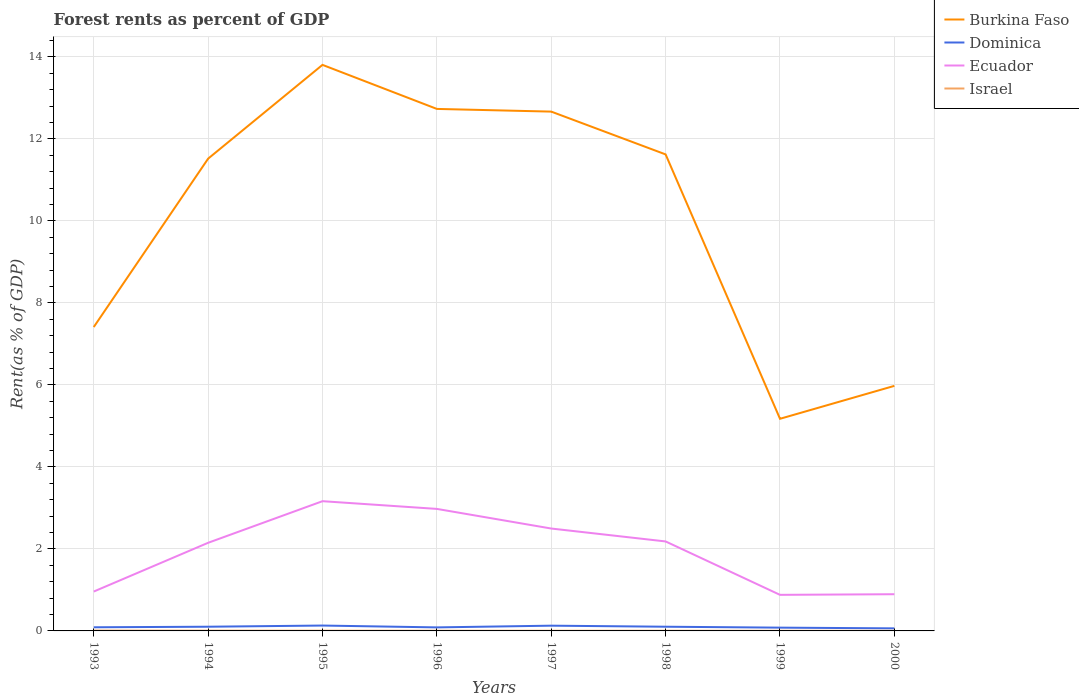How many different coloured lines are there?
Your answer should be compact. 4. Across all years, what is the maximum forest rent in Ecuador?
Offer a terse response. 0.88. What is the total forest rent in Israel in the graph?
Make the answer very short. 0. What is the difference between the highest and the second highest forest rent in Ecuador?
Keep it short and to the point. 2.28. What is the difference between the highest and the lowest forest rent in Dominica?
Your answer should be compact. 4. Is the forest rent in Israel strictly greater than the forest rent in Dominica over the years?
Give a very brief answer. Yes. How many lines are there?
Provide a short and direct response. 4. How many years are there in the graph?
Your response must be concise. 8. What is the difference between two consecutive major ticks on the Y-axis?
Your answer should be very brief. 2. Are the values on the major ticks of Y-axis written in scientific E-notation?
Provide a succinct answer. No. Does the graph contain grids?
Offer a very short reply. Yes. Where does the legend appear in the graph?
Your answer should be very brief. Top right. How are the legend labels stacked?
Provide a short and direct response. Vertical. What is the title of the graph?
Offer a very short reply. Forest rents as percent of GDP. Does "Cyprus" appear as one of the legend labels in the graph?
Offer a very short reply. No. What is the label or title of the X-axis?
Provide a short and direct response. Years. What is the label or title of the Y-axis?
Make the answer very short. Rent(as % of GDP). What is the Rent(as % of GDP) of Burkina Faso in 1993?
Offer a terse response. 7.41. What is the Rent(as % of GDP) in Dominica in 1993?
Your answer should be compact. 0.09. What is the Rent(as % of GDP) in Ecuador in 1993?
Keep it short and to the point. 0.96. What is the Rent(as % of GDP) in Israel in 1993?
Provide a succinct answer. 0.01. What is the Rent(as % of GDP) of Burkina Faso in 1994?
Provide a succinct answer. 11.52. What is the Rent(as % of GDP) in Dominica in 1994?
Provide a succinct answer. 0.1. What is the Rent(as % of GDP) of Ecuador in 1994?
Keep it short and to the point. 2.15. What is the Rent(as % of GDP) in Israel in 1994?
Offer a terse response. 0.01. What is the Rent(as % of GDP) of Burkina Faso in 1995?
Your answer should be compact. 13.81. What is the Rent(as % of GDP) of Dominica in 1995?
Provide a succinct answer. 0.13. What is the Rent(as % of GDP) of Ecuador in 1995?
Provide a short and direct response. 3.16. What is the Rent(as % of GDP) in Israel in 1995?
Give a very brief answer. 0.01. What is the Rent(as % of GDP) in Burkina Faso in 1996?
Provide a succinct answer. 12.73. What is the Rent(as % of GDP) in Dominica in 1996?
Offer a very short reply. 0.09. What is the Rent(as % of GDP) in Ecuador in 1996?
Provide a short and direct response. 2.98. What is the Rent(as % of GDP) in Israel in 1996?
Ensure brevity in your answer.  0. What is the Rent(as % of GDP) in Burkina Faso in 1997?
Provide a succinct answer. 12.67. What is the Rent(as % of GDP) in Dominica in 1997?
Give a very brief answer. 0.13. What is the Rent(as % of GDP) in Ecuador in 1997?
Make the answer very short. 2.5. What is the Rent(as % of GDP) in Israel in 1997?
Keep it short and to the point. 0. What is the Rent(as % of GDP) of Burkina Faso in 1998?
Keep it short and to the point. 11.62. What is the Rent(as % of GDP) of Dominica in 1998?
Offer a terse response. 0.1. What is the Rent(as % of GDP) of Ecuador in 1998?
Your answer should be very brief. 2.18. What is the Rent(as % of GDP) of Israel in 1998?
Provide a succinct answer. 0. What is the Rent(as % of GDP) of Burkina Faso in 1999?
Ensure brevity in your answer.  5.17. What is the Rent(as % of GDP) in Dominica in 1999?
Keep it short and to the point. 0.08. What is the Rent(as % of GDP) of Ecuador in 1999?
Your response must be concise. 0.88. What is the Rent(as % of GDP) of Israel in 1999?
Make the answer very short. 0. What is the Rent(as % of GDP) of Burkina Faso in 2000?
Ensure brevity in your answer.  5.98. What is the Rent(as % of GDP) of Dominica in 2000?
Make the answer very short. 0.06. What is the Rent(as % of GDP) in Ecuador in 2000?
Provide a succinct answer. 0.9. What is the Rent(as % of GDP) of Israel in 2000?
Your answer should be very brief. 0. Across all years, what is the maximum Rent(as % of GDP) in Burkina Faso?
Offer a terse response. 13.81. Across all years, what is the maximum Rent(as % of GDP) in Dominica?
Your answer should be compact. 0.13. Across all years, what is the maximum Rent(as % of GDP) in Ecuador?
Provide a short and direct response. 3.16. Across all years, what is the maximum Rent(as % of GDP) of Israel?
Your answer should be compact. 0.01. Across all years, what is the minimum Rent(as % of GDP) in Burkina Faso?
Make the answer very short. 5.17. Across all years, what is the minimum Rent(as % of GDP) of Dominica?
Offer a very short reply. 0.06. Across all years, what is the minimum Rent(as % of GDP) of Ecuador?
Offer a very short reply. 0.88. Across all years, what is the minimum Rent(as % of GDP) in Israel?
Offer a very short reply. 0. What is the total Rent(as % of GDP) in Burkina Faso in the graph?
Ensure brevity in your answer.  80.91. What is the total Rent(as % of GDP) of Dominica in the graph?
Ensure brevity in your answer.  0.78. What is the total Rent(as % of GDP) of Ecuador in the graph?
Provide a succinct answer. 15.71. What is the total Rent(as % of GDP) in Israel in the graph?
Ensure brevity in your answer.  0.04. What is the difference between the Rent(as % of GDP) in Burkina Faso in 1993 and that in 1994?
Provide a succinct answer. -4.11. What is the difference between the Rent(as % of GDP) in Dominica in 1993 and that in 1994?
Offer a terse response. -0.01. What is the difference between the Rent(as % of GDP) in Ecuador in 1993 and that in 1994?
Provide a succinct answer. -1.19. What is the difference between the Rent(as % of GDP) in Israel in 1993 and that in 1994?
Your answer should be very brief. 0. What is the difference between the Rent(as % of GDP) of Burkina Faso in 1993 and that in 1995?
Provide a succinct answer. -6.39. What is the difference between the Rent(as % of GDP) in Dominica in 1993 and that in 1995?
Make the answer very short. -0.04. What is the difference between the Rent(as % of GDP) in Ecuador in 1993 and that in 1995?
Your answer should be compact. -2.2. What is the difference between the Rent(as % of GDP) of Israel in 1993 and that in 1995?
Your response must be concise. 0. What is the difference between the Rent(as % of GDP) in Burkina Faso in 1993 and that in 1996?
Offer a very short reply. -5.32. What is the difference between the Rent(as % of GDP) in Dominica in 1993 and that in 1996?
Offer a terse response. 0. What is the difference between the Rent(as % of GDP) of Ecuador in 1993 and that in 1996?
Ensure brevity in your answer.  -2.02. What is the difference between the Rent(as % of GDP) in Israel in 1993 and that in 1996?
Your answer should be compact. 0. What is the difference between the Rent(as % of GDP) of Burkina Faso in 1993 and that in 1997?
Offer a very short reply. -5.25. What is the difference between the Rent(as % of GDP) of Dominica in 1993 and that in 1997?
Your response must be concise. -0.04. What is the difference between the Rent(as % of GDP) of Ecuador in 1993 and that in 1997?
Keep it short and to the point. -1.54. What is the difference between the Rent(as % of GDP) of Israel in 1993 and that in 1997?
Make the answer very short. 0. What is the difference between the Rent(as % of GDP) of Burkina Faso in 1993 and that in 1998?
Your answer should be very brief. -4.21. What is the difference between the Rent(as % of GDP) in Dominica in 1993 and that in 1998?
Ensure brevity in your answer.  -0.01. What is the difference between the Rent(as % of GDP) in Ecuador in 1993 and that in 1998?
Make the answer very short. -1.22. What is the difference between the Rent(as % of GDP) of Israel in 1993 and that in 1998?
Give a very brief answer. 0. What is the difference between the Rent(as % of GDP) of Burkina Faso in 1993 and that in 1999?
Ensure brevity in your answer.  2.24. What is the difference between the Rent(as % of GDP) in Dominica in 1993 and that in 1999?
Your answer should be compact. 0.01. What is the difference between the Rent(as % of GDP) in Ecuador in 1993 and that in 1999?
Your answer should be very brief. 0.08. What is the difference between the Rent(as % of GDP) of Israel in 1993 and that in 1999?
Your answer should be very brief. 0. What is the difference between the Rent(as % of GDP) of Burkina Faso in 1993 and that in 2000?
Give a very brief answer. 1.44. What is the difference between the Rent(as % of GDP) of Dominica in 1993 and that in 2000?
Offer a terse response. 0.03. What is the difference between the Rent(as % of GDP) of Ecuador in 1993 and that in 2000?
Your answer should be compact. 0.07. What is the difference between the Rent(as % of GDP) of Israel in 1993 and that in 2000?
Give a very brief answer. 0.01. What is the difference between the Rent(as % of GDP) of Burkina Faso in 1994 and that in 1995?
Your answer should be very brief. -2.29. What is the difference between the Rent(as % of GDP) in Dominica in 1994 and that in 1995?
Your answer should be compact. -0.03. What is the difference between the Rent(as % of GDP) of Ecuador in 1994 and that in 1995?
Offer a terse response. -1.01. What is the difference between the Rent(as % of GDP) of Israel in 1994 and that in 1995?
Your response must be concise. 0. What is the difference between the Rent(as % of GDP) of Burkina Faso in 1994 and that in 1996?
Offer a terse response. -1.21. What is the difference between the Rent(as % of GDP) in Dominica in 1994 and that in 1996?
Provide a succinct answer. 0.02. What is the difference between the Rent(as % of GDP) in Ecuador in 1994 and that in 1996?
Keep it short and to the point. -0.83. What is the difference between the Rent(as % of GDP) in Israel in 1994 and that in 1996?
Keep it short and to the point. 0. What is the difference between the Rent(as % of GDP) of Burkina Faso in 1994 and that in 1997?
Give a very brief answer. -1.15. What is the difference between the Rent(as % of GDP) in Dominica in 1994 and that in 1997?
Offer a very short reply. -0.03. What is the difference between the Rent(as % of GDP) in Ecuador in 1994 and that in 1997?
Offer a terse response. -0.35. What is the difference between the Rent(as % of GDP) in Israel in 1994 and that in 1997?
Provide a succinct answer. 0. What is the difference between the Rent(as % of GDP) in Burkina Faso in 1994 and that in 1998?
Ensure brevity in your answer.  -0.1. What is the difference between the Rent(as % of GDP) of Dominica in 1994 and that in 1998?
Ensure brevity in your answer.  0. What is the difference between the Rent(as % of GDP) in Ecuador in 1994 and that in 1998?
Your answer should be compact. -0.03. What is the difference between the Rent(as % of GDP) of Israel in 1994 and that in 1998?
Keep it short and to the point. 0. What is the difference between the Rent(as % of GDP) in Burkina Faso in 1994 and that in 1999?
Offer a terse response. 6.35. What is the difference between the Rent(as % of GDP) of Dominica in 1994 and that in 1999?
Provide a succinct answer. 0.02. What is the difference between the Rent(as % of GDP) of Ecuador in 1994 and that in 1999?
Give a very brief answer. 1.27. What is the difference between the Rent(as % of GDP) of Israel in 1994 and that in 1999?
Your answer should be compact. 0. What is the difference between the Rent(as % of GDP) of Burkina Faso in 1994 and that in 2000?
Your answer should be very brief. 5.54. What is the difference between the Rent(as % of GDP) in Dominica in 1994 and that in 2000?
Give a very brief answer. 0.04. What is the difference between the Rent(as % of GDP) in Ecuador in 1994 and that in 2000?
Provide a succinct answer. 1.25. What is the difference between the Rent(as % of GDP) of Israel in 1994 and that in 2000?
Make the answer very short. 0. What is the difference between the Rent(as % of GDP) of Burkina Faso in 1995 and that in 1996?
Your answer should be compact. 1.07. What is the difference between the Rent(as % of GDP) in Dominica in 1995 and that in 1996?
Provide a short and direct response. 0.04. What is the difference between the Rent(as % of GDP) of Ecuador in 1995 and that in 1996?
Your answer should be very brief. 0.19. What is the difference between the Rent(as % of GDP) in Burkina Faso in 1995 and that in 1997?
Keep it short and to the point. 1.14. What is the difference between the Rent(as % of GDP) of Dominica in 1995 and that in 1997?
Give a very brief answer. 0. What is the difference between the Rent(as % of GDP) in Ecuador in 1995 and that in 1997?
Ensure brevity in your answer.  0.67. What is the difference between the Rent(as % of GDP) of Israel in 1995 and that in 1997?
Your answer should be compact. 0. What is the difference between the Rent(as % of GDP) in Burkina Faso in 1995 and that in 1998?
Offer a very short reply. 2.18. What is the difference between the Rent(as % of GDP) in Dominica in 1995 and that in 1998?
Keep it short and to the point. 0.03. What is the difference between the Rent(as % of GDP) of Ecuador in 1995 and that in 1998?
Make the answer very short. 0.98. What is the difference between the Rent(as % of GDP) of Israel in 1995 and that in 1998?
Offer a terse response. 0. What is the difference between the Rent(as % of GDP) in Burkina Faso in 1995 and that in 1999?
Keep it short and to the point. 8.63. What is the difference between the Rent(as % of GDP) in Dominica in 1995 and that in 1999?
Provide a succinct answer. 0.05. What is the difference between the Rent(as % of GDP) in Ecuador in 1995 and that in 1999?
Offer a terse response. 2.28. What is the difference between the Rent(as % of GDP) of Israel in 1995 and that in 1999?
Your answer should be compact. 0. What is the difference between the Rent(as % of GDP) of Burkina Faso in 1995 and that in 2000?
Your answer should be compact. 7.83. What is the difference between the Rent(as % of GDP) of Dominica in 1995 and that in 2000?
Give a very brief answer. 0.07. What is the difference between the Rent(as % of GDP) of Ecuador in 1995 and that in 2000?
Offer a very short reply. 2.27. What is the difference between the Rent(as % of GDP) in Israel in 1995 and that in 2000?
Offer a very short reply. 0. What is the difference between the Rent(as % of GDP) of Burkina Faso in 1996 and that in 1997?
Offer a very short reply. 0.07. What is the difference between the Rent(as % of GDP) of Dominica in 1996 and that in 1997?
Offer a terse response. -0.04. What is the difference between the Rent(as % of GDP) in Ecuador in 1996 and that in 1997?
Give a very brief answer. 0.48. What is the difference between the Rent(as % of GDP) in Israel in 1996 and that in 1997?
Give a very brief answer. -0. What is the difference between the Rent(as % of GDP) in Burkina Faso in 1996 and that in 1998?
Make the answer very short. 1.11. What is the difference between the Rent(as % of GDP) of Dominica in 1996 and that in 1998?
Ensure brevity in your answer.  -0.02. What is the difference between the Rent(as % of GDP) in Ecuador in 1996 and that in 1998?
Your response must be concise. 0.79. What is the difference between the Rent(as % of GDP) in Israel in 1996 and that in 1998?
Ensure brevity in your answer.  0. What is the difference between the Rent(as % of GDP) in Burkina Faso in 1996 and that in 1999?
Your answer should be compact. 7.56. What is the difference between the Rent(as % of GDP) in Dominica in 1996 and that in 1999?
Give a very brief answer. 0.01. What is the difference between the Rent(as % of GDP) of Ecuador in 1996 and that in 1999?
Provide a short and direct response. 2.1. What is the difference between the Rent(as % of GDP) of Israel in 1996 and that in 1999?
Ensure brevity in your answer.  0. What is the difference between the Rent(as % of GDP) of Burkina Faso in 1996 and that in 2000?
Offer a very short reply. 6.76. What is the difference between the Rent(as % of GDP) of Dominica in 1996 and that in 2000?
Give a very brief answer. 0.02. What is the difference between the Rent(as % of GDP) of Ecuador in 1996 and that in 2000?
Make the answer very short. 2.08. What is the difference between the Rent(as % of GDP) of Israel in 1996 and that in 2000?
Keep it short and to the point. 0. What is the difference between the Rent(as % of GDP) of Burkina Faso in 1997 and that in 1998?
Your answer should be very brief. 1.04. What is the difference between the Rent(as % of GDP) in Dominica in 1997 and that in 1998?
Your answer should be compact. 0.03. What is the difference between the Rent(as % of GDP) of Ecuador in 1997 and that in 1998?
Your answer should be compact. 0.32. What is the difference between the Rent(as % of GDP) of Israel in 1997 and that in 1998?
Give a very brief answer. 0. What is the difference between the Rent(as % of GDP) of Burkina Faso in 1997 and that in 1999?
Ensure brevity in your answer.  7.49. What is the difference between the Rent(as % of GDP) of Dominica in 1997 and that in 1999?
Ensure brevity in your answer.  0.05. What is the difference between the Rent(as % of GDP) of Ecuador in 1997 and that in 1999?
Make the answer very short. 1.62. What is the difference between the Rent(as % of GDP) in Israel in 1997 and that in 1999?
Your response must be concise. 0. What is the difference between the Rent(as % of GDP) of Burkina Faso in 1997 and that in 2000?
Offer a terse response. 6.69. What is the difference between the Rent(as % of GDP) in Dominica in 1997 and that in 2000?
Provide a succinct answer. 0.07. What is the difference between the Rent(as % of GDP) in Ecuador in 1997 and that in 2000?
Offer a very short reply. 1.6. What is the difference between the Rent(as % of GDP) in Israel in 1997 and that in 2000?
Ensure brevity in your answer.  0. What is the difference between the Rent(as % of GDP) of Burkina Faso in 1998 and that in 1999?
Keep it short and to the point. 6.45. What is the difference between the Rent(as % of GDP) of Dominica in 1998 and that in 1999?
Ensure brevity in your answer.  0.02. What is the difference between the Rent(as % of GDP) of Ecuador in 1998 and that in 1999?
Keep it short and to the point. 1.3. What is the difference between the Rent(as % of GDP) in Burkina Faso in 1998 and that in 2000?
Offer a very short reply. 5.65. What is the difference between the Rent(as % of GDP) of Dominica in 1998 and that in 2000?
Keep it short and to the point. 0.04. What is the difference between the Rent(as % of GDP) in Ecuador in 1998 and that in 2000?
Provide a succinct answer. 1.29. What is the difference between the Rent(as % of GDP) of Israel in 1998 and that in 2000?
Make the answer very short. 0. What is the difference between the Rent(as % of GDP) in Burkina Faso in 1999 and that in 2000?
Keep it short and to the point. -0.8. What is the difference between the Rent(as % of GDP) of Dominica in 1999 and that in 2000?
Your answer should be very brief. 0.02. What is the difference between the Rent(as % of GDP) of Ecuador in 1999 and that in 2000?
Offer a very short reply. -0.02. What is the difference between the Rent(as % of GDP) in Israel in 1999 and that in 2000?
Ensure brevity in your answer.  0. What is the difference between the Rent(as % of GDP) of Burkina Faso in 1993 and the Rent(as % of GDP) of Dominica in 1994?
Your answer should be very brief. 7.31. What is the difference between the Rent(as % of GDP) in Burkina Faso in 1993 and the Rent(as % of GDP) in Ecuador in 1994?
Give a very brief answer. 5.26. What is the difference between the Rent(as % of GDP) of Burkina Faso in 1993 and the Rent(as % of GDP) of Israel in 1994?
Ensure brevity in your answer.  7.41. What is the difference between the Rent(as % of GDP) of Dominica in 1993 and the Rent(as % of GDP) of Ecuador in 1994?
Offer a very short reply. -2.06. What is the difference between the Rent(as % of GDP) of Dominica in 1993 and the Rent(as % of GDP) of Israel in 1994?
Offer a very short reply. 0.08. What is the difference between the Rent(as % of GDP) of Ecuador in 1993 and the Rent(as % of GDP) of Israel in 1994?
Make the answer very short. 0.95. What is the difference between the Rent(as % of GDP) in Burkina Faso in 1993 and the Rent(as % of GDP) in Dominica in 1995?
Provide a short and direct response. 7.28. What is the difference between the Rent(as % of GDP) of Burkina Faso in 1993 and the Rent(as % of GDP) of Ecuador in 1995?
Provide a short and direct response. 4.25. What is the difference between the Rent(as % of GDP) of Burkina Faso in 1993 and the Rent(as % of GDP) of Israel in 1995?
Your response must be concise. 7.41. What is the difference between the Rent(as % of GDP) in Dominica in 1993 and the Rent(as % of GDP) in Ecuador in 1995?
Offer a very short reply. -3.08. What is the difference between the Rent(as % of GDP) of Dominica in 1993 and the Rent(as % of GDP) of Israel in 1995?
Provide a succinct answer. 0.08. What is the difference between the Rent(as % of GDP) of Ecuador in 1993 and the Rent(as % of GDP) of Israel in 1995?
Offer a very short reply. 0.95. What is the difference between the Rent(as % of GDP) in Burkina Faso in 1993 and the Rent(as % of GDP) in Dominica in 1996?
Your answer should be compact. 7.33. What is the difference between the Rent(as % of GDP) of Burkina Faso in 1993 and the Rent(as % of GDP) of Ecuador in 1996?
Ensure brevity in your answer.  4.44. What is the difference between the Rent(as % of GDP) of Burkina Faso in 1993 and the Rent(as % of GDP) of Israel in 1996?
Keep it short and to the point. 7.41. What is the difference between the Rent(as % of GDP) of Dominica in 1993 and the Rent(as % of GDP) of Ecuador in 1996?
Your answer should be compact. -2.89. What is the difference between the Rent(as % of GDP) in Dominica in 1993 and the Rent(as % of GDP) in Israel in 1996?
Your response must be concise. 0.08. What is the difference between the Rent(as % of GDP) in Ecuador in 1993 and the Rent(as % of GDP) in Israel in 1996?
Make the answer very short. 0.96. What is the difference between the Rent(as % of GDP) in Burkina Faso in 1993 and the Rent(as % of GDP) in Dominica in 1997?
Ensure brevity in your answer.  7.28. What is the difference between the Rent(as % of GDP) of Burkina Faso in 1993 and the Rent(as % of GDP) of Ecuador in 1997?
Keep it short and to the point. 4.92. What is the difference between the Rent(as % of GDP) of Burkina Faso in 1993 and the Rent(as % of GDP) of Israel in 1997?
Your answer should be compact. 7.41. What is the difference between the Rent(as % of GDP) of Dominica in 1993 and the Rent(as % of GDP) of Ecuador in 1997?
Give a very brief answer. -2.41. What is the difference between the Rent(as % of GDP) of Dominica in 1993 and the Rent(as % of GDP) of Israel in 1997?
Ensure brevity in your answer.  0.08. What is the difference between the Rent(as % of GDP) of Ecuador in 1993 and the Rent(as % of GDP) of Israel in 1997?
Provide a succinct answer. 0.96. What is the difference between the Rent(as % of GDP) in Burkina Faso in 1993 and the Rent(as % of GDP) in Dominica in 1998?
Your response must be concise. 7.31. What is the difference between the Rent(as % of GDP) in Burkina Faso in 1993 and the Rent(as % of GDP) in Ecuador in 1998?
Provide a short and direct response. 5.23. What is the difference between the Rent(as % of GDP) in Burkina Faso in 1993 and the Rent(as % of GDP) in Israel in 1998?
Make the answer very short. 7.41. What is the difference between the Rent(as % of GDP) in Dominica in 1993 and the Rent(as % of GDP) in Ecuador in 1998?
Ensure brevity in your answer.  -2.09. What is the difference between the Rent(as % of GDP) of Dominica in 1993 and the Rent(as % of GDP) of Israel in 1998?
Provide a succinct answer. 0.08. What is the difference between the Rent(as % of GDP) in Ecuador in 1993 and the Rent(as % of GDP) in Israel in 1998?
Make the answer very short. 0.96. What is the difference between the Rent(as % of GDP) of Burkina Faso in 1993 and the Rent(as % of GDP) of Dominica in 1999?
Your answer should be compact. 7.33. What is the difference between the Rent(as % of GDP) in Burkina Faso in 1993 and the Rent(as % of GDP) in Ecuador in 1999?
Ensure brevity in your answer.  6.53. What is the difference between the Rent(as % of GDP) of Burkina Faso in 1993 and the Rent(as % of GDP) of Israel in 1999?
Your answer should be compact. 7.41. What is the difference between the Rent(as % of GDP) of Dominica in 1993 and the Rent(as % of GDP) of Ecuador in 1999?
Your response must be concise. -0.79. What is the difference between the Rent(as % of GDP) of Dominica in 1993 and the Rent(as % of GDP) of Israel in 1999?
Make the answer very short. 0.09. What is the difference between the Rent(as % of GDP) of Burkina Faso in 1993 and the Rent(as % of GDP) of Dominica in 2000?
Your answer should be compact. 7.35. What is the difference between the Rent(as % of GDP) in Burkina Faso in 1993 and the Rent(as % of GDP) in Ecuador in 2000?
Provide a succinct answer. 6.52. What is the difference between the Rent(as % of GDP) of Burkina Faso in 1993 and the Rent(as % of GDP) of Israel in 2000?
Your answer should be compact. 7.41. What is the difference between the Rent(as % of GDP) of Dominica in 1993 and the Rent(as % of GDP) of Ecuador in 2000?
Offer a terse response. -0.81. What is the difference between the Rent(as % of GDP) in Dominica in 1993 and the Rent(as % of GDP) in Israel in 2000?
Your response must be concise. 0.09. What is the difference between the Rent(as % of GDP) in Ecuador in 1993 and the Rent(as % of GDP) in Israel in 2000?
Offer a terse response. 0.96. What is the difference between the Rent(as % of GDP) of Burkina Faso in 1994 and the Rent(as % of GDP) of Dominica in 1995?
Provide a short and direct response. 11.39. What is the difference between the Rent(as % of GDP) in Burkina Faso in 1994 and the Rent(as % of GDP) in Ecuador in 1995?
Give a very brief answer. 8.36. What is the difference between the Rent(as % of GDP) of Burkina Faso in 1994 and the Rent(as % of GDP) of Israel in 1995?
Ensure brevity in your answer.  11.51. What is the difference between the Rent(as % of GDP) of Dominica in 1994 and the Rent(as % of GDP) of Ecuador in 1995?
Your response must be concise. -3.06. What is the difference between the Rent(as % of GDP) of Dominica in 1994 and the Rent(as % of GDP) of Israel in 1995?
Offer a terse response. 0.1. What is the difference between the Rent(as % of GDP) in Ecuador in 1994 and the Rent(as % of GDP) in Israel in 1995?
Your answer should be very brief. 2.14. What is the difference between the Rent(as % of GDP) in Burkina Faso in 1994 and the Rent(as % of GDP) in Dominica in 1996?
Provide a short and direct response. 11.43. What is the difference between the Rent(as % of GDP) of Burkina Faso in 1994 and the Rent(as % of GDP) of Ecuador in 1996?
Make the answer very short. 8.54. What is the difference between the Rent(as % of GDP) in Burkina Faso in 1994 and the Rent(as % of GDP) in Israel in 1996?
Make the answer very short. 11.52. What is the difference between the Rent(as % of GDP) of Dominica in 1994 and the Rent(as % of GDP) of Ecuador in 1996?
Your answer should be compact. -2.87. What is the difference between the Rent(as % of GDP) of Dominica in 1994 and the Rent(as % of GDP) of Israel in 1996?
Your answer should be very brief. 0.1. What is the difference between the Rent(as % of GDP) of Ecuador in 1994 and the Rent(as % of GDP) of Israel in 1996?
Your answer should be compact. 2.15. What is the difference between the Rent(as % of GDP) in Burkina Faso in 1994 and the Rent(as % of GDP) in Dominica in 1997?
Provide a short and direct response. 11.39. What is the difference between the Rent(as % of GDP) of Burkina Faso in 1994 and the Rent(as % of GDP) of Ecuador in 1997?
Your response must be concise. 9.02. What is the difference between the Rent(as % of GDP) of Burkina Faso in 1994 and the Rent(as % of GDP) of Israel in 1997?
Your response must be concise. 11.52. What is the difference between the Rent(as % of GDP) in Dominica in 1994 and the Rent(as % of GDP) in Ecuador in 1997?
Ensure brevity in your answer.  -2.4. What is the difference between the Rent(as % of GDP) in Dominica in 1994 and the Rent(as % of GDP) in Israel in 1997?
Offer a terse response. 0.1. What is the difference between the Rent(as % of GDP) of Ecuador in 1994 and the Rent(as % of GDP) of Israel in 1997?
Provide a short and direct response. 2.15. What is the difference between the Rent(as % of GDP) of Burkina Faso in 1994 and the Rent(as % of GDP) of Dominica in 1998?
Offer a very short reply. 11.42. What is the difference between the Rent(as % of GDP) of Burkina Faso in 1994 and the Rent(as % of GDP) of Ecuador in 1998?
Your answer should be compact. 9.34. What is the difference between the Rent(as % of GDP) in Burkina Faso in 1994 and the Rent(as % of GDP) in Israel in 1998?
Your response must be concise. 11.52. What is the difference between the Rent(as % of GDP) in Dominica in 1994 and the Rent(as % of GDP) in Ecuador in 1998?
Offer a very short reply. -2.08. What is the difference between the Rent(as % of GDP) in Dominica in 1994 and the Rent(as % of GDP) in Israel in 1998?
Give a very brief answer. 0.1. What is the difference between the Rent(as % of GDP) of Ecuador in 1994 and the Rent(as % of GDP) of Israel in 1998?
Your answer should be very brief. 2.15. What is the difference between the Rent(as % of GDP) in Burkina Faso in 1994 and the Rent(as % of GDP) in Dominica in 1999?
Keep it short and to the point. 11.44. What is the difference between the Rent(as % of GDP) in Burkina Faso in 1994 and the Rent(as % of GDP) in Ecuador in 1999?
Your answer should be compact. 10.64. What is the difference between the Rent(as % of GDP) in Burkina Faso in 1994 and the Rent(as % of GDP) in Israel in 1999?
Your answer should be very brief. 11.52. What is the difference between the Rent(as % of GDP) in Dominica in 1994 and the Rent(as % of GDP) in Ecuador in 1999?
Provide a succinct answer. -0.78. What is the difference between the Rent(as % of GDP) of Dominica in 1994 and the Rent(as % of GDP) of Israel in 1999?
Give a very brief answer. 0.1. What is the difference between the Rent(as % of GDP) in Ecuador in 1994 and the Rent(as % of GDP) in Israel in 1999?
Give a very brief answer. 2.15. What is the difference between the Rent(as % of GDP) in Burkina Faso in 1994 and the Rent(as % of GDP) in Dominica in 2000?
Your answer should be very brief. 11.46. What is the difference between the Rent(as % of GDP) of Burkina Faso in 1994 and the Rent(as % of GDP) of Ecuador in 2000?
Ensure brevity in your answer.  10.62. What is the difference between the Rent(as % of GDP) in Burkina Faso in 1994 and the Rent(as % of GDP) in Israel in 2000?
Provide a short and direct response. 11.52. What is the difference between the Rent(as % of GDP) in Dominica in 1994 and the Rent(as % of GDP) in Ecuador in 2000?
Provide a succinct answer. -0.79. What is the difference between the Rent(as % of GDP) in Dominica in 1994 and the Rent(as % of GDP) in Israel in 2000?
Your answer should be very brief. 0.1. What is the difference between the Rent(as % of GDP) of Ecuador in 1994 and the Rent(as % of GDP) of Israel in 2000?
Your response must be concise. 2.15. What is the difference between the Rent(as % of GDP) in Burkina Faso in 1995 and the Rent(as % of GDP) in Dominica in 1996?
Provide a succinct answer. 13.72. What is the difference between the Rent(as % of GDP) of Burkina Faso in 1995 and the Rent(as % of GDP) of Ecuador in 1996?
Provide a succinct answer. 10.83. What is the difference between the Rent(as % of GDP) in Burkina Faso in 1995 and the Rent(as % of GDP) in Israel in 1996?
Your response must be concise. 13.8. What is the difference between the Rent(as % of GDP) of Dominica in 1995 and the Rent(as % of GDP) of Ecuador in 1996?
Your answer should be compact. -2.85. What is the difference between the Rent(as % of GDP) in Dominica in 1995 and the Rent(as % of GDP) in Israel in 1996?
Your answer should be very brief. 0.13. What is the difference between the Rent(as % of GDP) in Ecuador in 1995 and the Rent(as % of GDP) in Israel in 1996?
Your answer should be compact. 3.16. What is the difference between the Rent(as % of GDP) of Burkina Faso in 1995 and the Rent(as % of GDP) of Dominica in 1997?
Ensure brevity in your answer.  13.68. What is the difference between the Rent(as % of GDP) in Burkina Faso in 1995 and the Rent(as % of GDP) in Ecuador in 1997?
Provide a succinct answer. 11.31. What is the difference between the Rent(as % of GDP) in Burkina Faso in 1995 and the Rent(as % of GDP) in Israel in 1997?
Your answer should be very brief. 13.8. What is the difference between the Rent(as % of GDP) in Dominica in 1995 and the Rent(as % of GDP) in Ecuador in 1997?
Provide a succinct answer. -2.37. What is the difference between the Rent(as % of GDP) of Dominica in 1995 and the Rent(as % of GDP) of Israel in 1997?
Provide a succinct answer. 0.13. What is the difference between the Rent(as % of GDP) of Ecuador in 1995 and the Rent(as % of GDP) of Israel in 1997?
Offer a terse response. 3.16. What is the difference between the Rent(as % of GDP) of Burkina Faso in 1995 and the Rent(as % of GDP) of Dominica in 1998?
Provide a succinct answer. 13.7. What is the difference between the Rent(as % of GDP) of Burkina Faso in 1995 and the Rent(as % of GDP) of Ecuador in 1998?
Provide a short and direct response. 11.62. What is the difference between the Rent(as % of GDP) of Burkina Faso in 1995 and the Rent(as % of GDP) of Israel in 1998?
Offer a very short reply. 13.8. What is the difference between the Rent(as % of GDP) in Dominica in 1995 and the Rent(as % of GDP) in Ecuador in 1998?
Offer a terse response. -2.05. What is the difference between the Rent(as % of GDP) of Dominica in 1995 and the Rent(as % of GDP) of Israel in 1998?
Your answer should be very brief. 0.13. What is the difference between the Rent(as % of GDP) of Ecuador in 1995 and the Rent(as % of GDP) of Israel in 1998?
Make the answer very short. 3.16. What is the difference between the Rent(as % of GDP) of Burkina Faso in 1995 and the Rent(as % of GDP) of Dominica in 1999?
Give a very brief answer. 13.73. What is the difference between the Rent(as % of GDP) in Burkina Faso in 1995 and the Rent(as % of GDP) in Ecuador in 1999?
Offer a very short reply. 12.93. What is the difference between the Rent(as % of GDP) in Burkina Faso in 1995 and the Rent(as % of GDP) in Israel in 1999?
Offer a very short reply. 13.8. What is the difference between the Rent(as % of GDP) of Dominica in 1995 and the Rent(as % of GDP) of Ecuador in 1999?
Your response must be concise. -0.75. What is the difference between the Rent(as % of GDP) in Dominica in 1995 and the Rent(as % of GDP) in Israel in 1999?
Offer a very short reply. 0.13. What is the difference between the Rent(as % of GDP) in Ecuador in 1995 and the Rent(as % of GDP) in Israel in 1999?
Provide a succinct answer. 3.16. What is the difference between the Rent(as % of GDP) of Burkina Faso in 1995 and the Rent(as % of GDP) of Dominica in 2000?
Your response must be concise. 13.74. What is the difference between the Rent(as % of GDP) of Burkina Faso in 1995 and the Rent(as % of GDP) of Ecuador in 2000?
Provide a short and direct response. 12.91. What is the difference between the Rent(as % of GDP) in Burkina Faso in 1995 and the Rent(as % of GDP) in Israel in 2000?
Ensure brevity in your answer.  13.8. What is the difference between the Rent(as % of GDP) of Dominica in 1995 and the Rent(as % of GDP) of Ecuador in 2000?
Offer a very short reply. -0.76. What is the difference between the Rent(as % of GDP) in Dominica in 1995 and the Rent(as % of GDP) in Israel in 2000?
Provide a succinct answer. 0.13. What is the difference between the Rent(as % of GDP) of Ecuador in 1995 and the Rent(as % of GDP) of Israel in 2000?
Your answer should be compact. 3.16. What is the difference between the Rent(as % of GDP) of Burkina Faso in 1996 and the Rent(as % of GDP) of Dominica in 1997?
Provide a short and direct response. 12.6. What is the difference between the Rent(as % of GDP) in Burkina Faso in 1996 and the Rent(as % of GDP) in Ecuador in 1997?
Provide a short and direct response. 10.24. What is the difference between the Rent(as % of GDP) in Burkina Faso in 1996 and the Rent(as % of GDP) in Israel in 1997?
Offer a terse response. 12.73. What is the difference between the Rent(as % of GDP) of Dominica in 1996 and the Rent(as % of GDP) of Ecuador in 1997?
Make the answer very short. -2.41. What is the difference between the Rent(as % of GDP) of Dominica in 1996 and the Rent(as % of GDP) of Israel in 1997?
Provide a short and direct response. 0.08. What is the difference between the Rent(as % of GDP) of Ecuador in 1996 and the Rent(as % of GDP) of Israel in 1997?
Provide a succinct answer. 2.97. What is the difference between the Rent(as % of GDP) of Burkina Faso in 1996 and the Rent(as % of GDP) of Dominica in 1998?
Keep it short and to the point. 12.63. What is the difference between the Rent(as % of GDP) in Burkina Faso in 1996 and the Rent(as % of GDP) in Ecuador in 1998?
Provide a succinct answer. 10.55. What is the difference between the Rent(as % of GDP) in Burkina Faso in 1996 and the Rent(as % of GDP) in Israel in 1998?
Provide a short and direct response. 12.73. What is the difference between the Rent(as % of GDP) in Dominica in 1996 and the Rent(as % of GDP) in Ecuador in 1998?
Provide a succinct answer. -2.1. What is the difference between the Rent(as % of GDP) of Dominica in 1996 and the Rent(as % of GDP) of Israel in 1998?
Your response must be concise. 0.08. What is the difference between the Rent(as % of GDP) in Ecuador in 1996 and the Rent(as % of GDP) in Israel in 1998?
Offer a terse response. 2.97. What is the difference between the Rent(as % of GDP) in Burkina Faso in 1996 and the Rent(as % of GDP) in Dominica in 1999?
Provide a succinct answer. 12.65. What is the difference between the Rent(as % of GDP) in Burkina Faso in 1996 and the Rent(as % of GDP) in Ecuador in 1999?
Your answer should be compact. 11.85. What is the difference between the Rent(as % of GDP) of Burkina Faso in 1996 and the Rent(as % of GDP) of Israel in 1999?
Your answer should be compact. 12.73. What is the difference between the Rent(as % of GDP) in Dominica in 1996 and the Rent(as % of GDP) in Ecuador in 1999?
Offer a very short reply. -0.79. What is the difference between the Rent(as % of GDP) in Dominica in 1996 and the Rent(as % of GDP) in Israel in 1999?
Make the answer very short. 0.08. What is the difference between the Rent(as % of GDP) in Ecuador in 1996 and the Rent(as % of GDP) in Israel in 1999?
Provide a short and direct response. 2.97. What is the difference between the Rent(as % of GDP) in Burkina Faso in 1996 and the Rent(as % of GDP) in Dominica in 2000?
Your response must be concise. 12.67. What is the difference between the Rent(as % of GDP) of Burkina Faso in 1996 and the Rent(as % of GDP) of Ecuador in 2000?
Keep it short and to the point. 11.84. What is the difference between the Rent(as % of GDP) of Burkina Faso in 1996 and the Rent(as % of GDP) of Israel in 2000?
Your response must be concise. 12.73. What is the difference between the Rent(as % of GDP) in Dominica in 1996 and the Rent(as % of GDP) in Ecuador in 2000?
Ensure brevity in your answer.  -0.81. What is the difference between the Rent(as % of GDP) in Dominica in 1996 and the Rent(as % of GDP) in Israel in 2000?
Make the answer very short. 0.08. What is the difference between the Rent(as % of GDP) of Ecuador in 1996 and the Rent(as % of GDP) of Israel in 2000?
Ensure brevity in your answer.  2.97. What is the difference between the Rent(as % of GDP) of Burkina Faso in 1997 and the Rent(as % of GDP) of Dominica in 1998?
Your answer should be very brief. 12.56. What is the difference between the Rent(as % of GDP) of Burkina Faso in 1997 and the Rent(as % of GDP) of Ecuador in 1998?
Offer a terse response. 10.48. What is the difference between the Rent(as % of GDP) of Burkina Faso in 1997 and the Rent(as % of GDP) of Israel in 1998?
Provide a short and direct response. 12.66. What is the difference between the Rent(as % of GDP) of Dominica in 1997 and the Rent(as % of GDP) of Ecuador in 1998?
Keep it short and to the point. -2.05. What is the difference between the Rent(as % of GDP) in Dominica in 1997 and the Rent(as % of GDP) in Israel in 1998?
Ensure brevity in your answer.  0.12. What is the difference between the Rent(as % of GDP) of Ecuador in 1997 and the Rent(as % of GDP) of Israel in 1998?
Make the answer very short. 2.49. What is the difference between the Rent(as % of GDP) in Burkina Faso in 1997 and the Rent(as % of GDP) in Dominica in 1999?
Your answer should be very brief. 12.59. What is the difference between the Rent(as % of GDP) of Burkina Faso in 1997 and the Rent(as % of GDP) of Ecuador in 1999?
Offer a very short reply. 11.79. What is the difference between the Rent(as % of GDP) in Burkina Faso in 1997 and the Rent(as % of GDP) in Israel in 1999?
Make the answer very short. 12.66. What is the difference between the Rent(as % of GDP) in Dominica in 1997 and the Rent(as % of GDP) in Ecuador in 1999?
Provide a succinct answer. -0.75. What is the difference between the Rent(as % of GDP) of Dominica in 1997 and the Rent(as % of GDP) of Israel in 1999?
Make the answer very short. 0.12. What is the difference between the Rent(as % of GDP) of Ecuador in 1997 and the Rent(as % of GDP) of Israel in 1999?
Your answer should be very brief. 2.49. What is the difference between the Rent(as % of GDP) of Burkina Faso in 1997 and the Rent(as % of GDP) of Dominica in 2000?
Your answer should be compact. 12.6. What is the difference between the Rent(as % of GDP) in Burkina Faso in 1997 and the Rent(as % of GDP) in Ecuador in 2000?
Your answer should be very brief. 11.77. What is the difference between the Rent(as % of GDP) of Burkina Faso in 1997 and the Rent(as % of GDP) of Israel in 2000?
Your answer should be very brief. 12.66. What is the difference between the Rent(as % of GDP) in Dominica in 1997 and the Rent(as % of GDP) in Ecuador in 2000?
Your answer should be very brief. -0.77. What is the difference between the Rent(as % of GDP) in Dominica in 1997 and the Rent(as % of GDP) in Israel in 2000?
Keep it short and to the point. 0.13. What is the difference between the Rent(as % of GDP) of Ecuador in 1997 and the Rent(as % of GDP) of Israel in 2000?
Provide a succinct answer. 2.5. What is the difference between the Rent(as % of GDP) of Burkina Faso in 1998 and the Rent(as % of GDP) of Dominica in 1999?
Your response must be concise. 11.54. What is the difference between the Rent(as % of GDP) of Burkina Faso in 1998 and the Rent(as % of GDP) of Ecuador in 1999?
Give a very brief answer. 10.74. What is the difference between the Rent(as % of GDP) of Burkina Faso in 1998 and the Rent(as % of GDP) of Israel in 1999?
Ensure brevity in your answer.  11.62. What is the difference between the Rent(as % of GDP) of Dominica in 1998 and the Rent(as % of GDP) of Ecuador in 1999?
Give a very brief answer. -0.78. What is the difference between the Rent(as % of GDP) of Dominica in 1998 and the Rent(as % of GDP) of Israel in 1999?
Give a very brief answer. 0.1. What is the difference between the Rent(as % of GDP) of Ecuador in 1998 and the Rent(as % of GDP) of Israel in 1999?
Your answer should be very brief. 2.18. What is the difference between the Rent(as % of GDP) in Burkina Faso in 1998 and the Rent(as % of GDP) in Dominica in 2000?
Provide a short and direct response. 11.56. What is the difference between the Rent(as % of GDP) of Burkina Faso in 1998 and the Rent(as % of GDP) of Ecuador in 2000?
Keep it short and to the point. 10.73. What is the difference between the Rent(as % of GDP) in Burkina Faso in 1998 and the Rent(as % of GDP) in Israel in 2000?
Provide a succinct answer. 11.62. What is the difference between the Rent(as % of GDP) in Dominica in 1998 and the Rent(as % of GDP) in Ecuador in 2000?
Your answer should be very brief. -0.79. What is the difference between the Rent(as % of GDP) in Dominica in 1998 and the Rent(as % of GDP) in Israel in 2000?
Offer a terse response. 0.1. What is the difference between the Rent(as % of GDP) of Ecuador in 1998 and the Rent(as % of GDP) of Israel in 2000?
Your answer should be very brief. 2.18. What is the difference between the Rent(as % of GDP) in Burkina Faso in 1999 and the Rent(as % of GDP) in Dominica in 2000?
Provide a short and direct response. 5.11. What is the difference between the Rent(as % of GDP) of Burkina Faso in 1999 and the Rent(as % of GDP) of Ecuador in 2000?
Ensure brevity in your answer.  4.28. What is the difference between the Rent(as % of GDP) in Burkina Faso in 1999 and the Rent(as % of GDP) in Israel in 2000?
Offer a very short reply. 5.17. What is the difference between the Rent(as % of GDP) of Dominica in 1999 and the Rent(as % of GDP) of Ecuador in 2000?
Your response must be concise. -0.82. What is the difference between the Rent(as % of GDP) in Dominica in 1999 and the Rent(as % of GDP) in Israel in 2000?
Offer a very short reply. 0.08. What is the difference between the Rent(as % of GDP) of Ecuador in 1999 and the Rent(as % of GDP) of Israel in 2000?
Ensure brevity in your answer.  0.88. What is the average Rent(as % of GDP) of Burkina Faso per year?
Your answer should be very brief. 10.11. What is the average Rent(as % of GDP) of Dominica per year?
Your response must be concise. 0.1. What is the average Rent(as % of GDP) in Ecuador per year?
Your answer should be very brief. 1.96. What is the average Rent(as % of GDP) of Israel per year?
Your answer should be very brief. 0. In the year 1993, what is the difference between the Rent(as % of GDP) in Burkina Faso and Rent(as % of GDP) in Dominica?
Provide a succinct answer. 7.32. In the year 1993, what is the difference between the Rent(as % of GDP) of Burkina Faso and Rent(as % of GDP) of Ecuador?
Give a very brief answer. 6.45. In the year 1993, what is the difference between the Rent(as % of GDP) in Burkina Faso and Rent(as % of GDP) in Israel?
Your answer should be compact. 7.4. In the year 1993, what is the difference between the Rent(as % of GDP) of Dominica and Rent(as % of GDP) of Ecuador?
Offer a very short reply. -0.87. In the year 1993, what is the difference between the Rent(as % of GDP) in Dominica and Rent(as % of GDP) in Israel?
Keep it short and to the point. 0.08. In the year 1993, what is the difference between the Rent(as % of GDP) of Ecuador and Rent(as % of GDP) of Israel?
Your answer should be compact. 0.95. In the year 1994, what is the difference between the Rent(as % of GDP) in Burkina Faso and Rent(as % of GDP) in Dominica?
Your response must be concise. 11.42. In the year 1994, what is the difference between the Rent(as % of GDP) in Burkina Faso and Rent(as % of GDP) in Ecuador?
Make the answer very short. 9.37. In the year 1994, what is the difference between the Rent(as % of GDP) in Burkina Faso and Rent(as % of GDP) in Israel?
Offer a terse response. 11.51. In the year 1994, what is the difference between the Rent(as % of GDP) of Dominica and Rent(as % of GDP) of Ecuador?
Make the answer very short. -2.05. In the year 1994, what is the difference between the Rent(as % of GDP) of Dominica and Rent(as % of GDP) of Israel?
Offer a terse response. 0.1. In the year 1994, what is the difference between the Rent(as % of GDP) of Ecuador and Rent(as % of GDP) of Israel?
Give a very brief answer. 2.14. In the year 1995, what is the difference between the Rent(as % of GDP) in Burkina Faso and Rent(as % of GDP) in Dominica?
Give a very brief answer. 13.68. In the year 1995, what is the difference between the Rent(as % of GDP) of Burkina Faso and Rent(as % of GDP) of Ecuador?
Provide a short and direct response. 10.64. In the year 1995, what is the difference between the Rent(as % of GDP) in Burkina Faso and Rent(as % of GDP) in Israel?
Your response must be concise. 13.8. In the year 1995, what is the difference between the Rent(as % of GDP) of Dominica and Rent(as % of GDP) of Ecuador?
Ensure brevity in your answer.  -3.03. In the year 1995, what is the difference between the Rent(as % of GDP) of Dominica and Rent(as % of GDP) of Israel?
Keep it short and to the point. 0.13. In the year 1995, what is the difference between the Rent(as % of GDP) in Ecuador and Rent(as % of GDP) in Israel?
Make the answer very short. 3.16. In the year 1996, what is the difference between the Rent(as % of GDP) in Burkina Faso and Rent(as % of GDP) in Dominica?
Ensure brevity in your answer.  12.65. In the year 1996, what is the difference between the Rent(as % of GDP) of Burkina Faso and Rent(as % of GDP) of Ecuador?
Offer a very short reply. 9.76. In the year 1996, what is the difference between the Rent(as % of GDP) in Burkina Faso and Rent(as % of GDP) in Israel?
Give a very brief answer. 12.73. In the year 1996, what is the difference between the Rent(as % of GDP) in Dominica and Rent(as % of GDP) in Ecuador?
Make the answer very short. -2.89. In the year 1996, what is the difference between the Rent(as % of GDP) in Dominica and Rent(as % of GDP) in Israel?
Your response must be concise. 0.08. In the year 1996, what is the difference between the Rent(as % of GDP) of Ecuador and Rent(as % of GDP) of Israel?
Offer a very short reply. 2.97. In the year 1997, what is the difference between the Rent(as % of GDP) in Burkina Faso and Rent(as % of GDP) in Dominica?
Give a very brief answer. 12.54. In the year 1997, what is the difference between the Rent(as % of GDP) of Burkina Faso and Rent(as % of GDP) of Ecuador?
Make the answer very short. 10.17. In the year 1997, what is the difference between the Rent(as % of GDP) of Burkina Faso and Rent(as % of GDP) of Israel?
Keep it short and to the point. 12.66. In the year 1997, what is the difference between the Rent(as % of GDP) of Dominica and Rent(as % of GDP) of Ecuador?
Provide a succinct answer. -2.37. In the year 1997, what is the difference between the Rent(as % of GDP) in Dominica and Rent(as % of GDP) in Israel?
Offer a terse response. 0.12. In the year 1997, what is the difference between the Rent(as % of GDP) in Ecuador and Rent(as % of GDP) in Israel?
Make the answer very short. 2.49. In the year 1998, what is the difference between the Rent(as % of GDP) in Burkina Faso and Rent(as % of GDP) in Dominica?
Your response must be concise. 11.52. In the year 1998, what is the difference between the Rent(as % of GDP) of Burkina Faso and Rent(as % of GDP) of Ecuador?
Your answer should be compact. 9.44. In the year 1998, what is the difference between the Rent(as % of GDP) of Burkina Faso and Rent(as % of GDP) of Israel?
Offer a terse response. 11.62. In the year 1998, what is the difference between the Rent(as % of GDP) of Dominica and Rent(as % of GDP) of Ecuador?
Offer a terse response. -2.08. In the year 1998, what is the difference between the Rent(as % of GDP) in Dominica and Rent(as % of GDP) in Israel?
Your response must be concise. 0.1. In the year 1998, what is the difference between the Rent(as % of GDP) of Ecuador and Rent(as % of GDP) of Israel?
Provide a short and direct response. 2.18. In the year 1999, what is the difference between the Rent(as % of GDP) in Burkina Faso and Rent(as % of GDP) in Dominica?
Offer a terse response. 5.09. In the year 1999, what is the difference between the Rent(as % of GDP) of Burkina Faso and Rent(as % of GDP) of Ecuador?
Offer a very short reply. 4.29. In the year 1999, what is the difference between the Rent(as % of GDP) in Burkina Faso and Rent(as % of GDP) in Israel?
Provide a succinct answer. 5.17. In the year 1999, what is the difference between the Rent(as % of GDP) in Dominica and Rent(as % of GDP) in Ecuador?
Keep it short and to the point. -0.8. In the year 1999, what is the difference between the Rent(as % of GDP) of Dominica and Rent(as % of GDP) of Israel?
Ensure brevity in your answer.  0.08. In the year 1999, what is the difference between the Rent(as % of GDP) in Ecuador and Rent(as % of GDP) in Israel?
Give a very brief answer. 0.88. In the year 2000, what is the difference between the Rent(as % of GDP) of Burkina Faso and Rent(as % of GDP) of Dominica?
Keep it short and to the point. 5.91. In the year 2000, what is the difference between the Rent(as % of GDP) of Burkina Faso and Rent(as % of GDP) of Ecuador?
Your answer should be very brief. 5.08. In the year 2000, what is the difference between the Rent(as % of GDP) in Burkina Faso and Rent(as % of GDP) in Israel?
Offer a terse response. 5.98. In the year 2000, what is the difference between the Rent(as % of GDP) of Dominica and Rent(as % of GDP) of Ecuador?
Keep it short and to the point. -0.83. In the year 2000, what is the difference between the Rent(as % of GDP) of Dominica and Rent(as % of GDP) of Israel?
Offer a very short reply. 0.06. In the year 2000, what is the difference between the Rent(as % of GDP) in Ecuador and Rent(as % of GDP) in Israel?
Your answer should be very brief. 0.89. What is the ratio of the Rent(as % of GDP) in Burkina Faso in 1993 to that in 1994?
Provide a short and direct response. 0.64. What is the ratio of the Rent(as % of GDP) of Dominica in 1993 to that in 1994?
Keep it short and to the point. 0.87. What is the ratio of the Rent(as % of GDP) of Ecuador in 1993 to that in 1994?
Your response must be concise. 0.45. What is the ratio of the Rent(as % of GDP) in Israel in 1993 to that in 1994?
Keep it short and to the point. 1.21. What is the ratio of the Rent(as % of GDP) of Burkina Faso in 1993 to that in 1995?
Ensure brevity in your answer.  0.54. What is the ratio of the Rent(as % of GDP) of Dominica in 1993 to that in 1995?
Offer a very short reply. 0.68. What is the ratio of the Rent(as % of GDP) in Ecuador in 1993 to that in 1995?
Keep it short and to the point. 0.3. What is the ratio of the Rent(as % of GDP) of Israel in 1993 to that in 1995?
Your answer should be compact. 1.47. What is the ratio of the Rent(as % of GDP) in Burkina Faso in 1993 to that in 1996?
Ensure brevity in your answer.  0.58. What is the ratio of the Rent(as % of GDP) of Dominica in 1993 to that in 1996?
Offer a very short reply. 1.03. What is the ratio of the Rent(as % of GDP) in Ecuador in 1993 to that in 1996?
Provide a succinct answer. 0.32. What is the ratio of the Rent(as % of GDP) in Israel in 1993 to that in 1996?
Provide a succinct answer. 1.81. What is the ratio of the Rent(as % of GDP) of Burkina Faso in 1993 to that in 1997?
Give a very brief answer. 0.59. What is the ratio of the Rent(as % of GDP) of Dominica in 1993 to that in 1997?
Provide a short and direct response. 0.69. What is the ratio of the Rent(as % of GDP) of Ecuador in 1993 to that in 1997?
Your response must be concise. 0.38. What is the ratio of the Rent(as % of GDP) in Israel in 1993 to that in 1997?
Give a very brief answer. 1.77. What is the ratio of the Rent(as % of GDP) in Burkina Faso in 1993 to that in 1998?
Your answer should be very brief. 0.64. What is the ratio of the Rent(as % of GDP) of Dominica in 1993 to that in 1998?
Your response must be concise. 0.87. What is the ratio of the Rent(as % of GDP) of Ecuador in 1993 to that in 1998?
Your response must be concise. 0.44. What is the ratio of the Rent(as % of GDP) in Israel in 1993 to that in 1998?
Provide a succinct answer. 2.06. What is the ratio of the Rent(as % of GDP) of Burkina Faso in 1993 to that in 1999?
Offer a terse response. 1.43. What is the ratio of the Rent(as % of GDP) of Dominica in 1993 to that in 1999?
Provide a short and direct response. 1.11. What is the ratio of the Rent(as % of GDP) in Ecuador in 1993 to that in 1999?
Provide a short and direct response. 1.09. What is the ratio of the Rent(as % of GDP) of Israel in 1993 to that in 1999?
Make the answer very short. 2.35. What is the ratio of the Rent(as % of GDP) of Burkina Faso in 1993 to that in 2000?
Keep it short and to the point. 1.24. What is the ratio of the Rent(as % of GDP) of Dominica in 1993 to that in 2000?
Your response must be concise. 1.42. What is the ratio of the Rent(as % of GDP) of Ecuador in 1993 to that in 2000?
Offer a very short reply. 1.07. What is the ratio of the Rent(as % of GDP) of Israel in 1993 to that in 2000?
Your response must be concise. 3.84. What is the ratio of the Rent(as % of GDP) in Burkina Faso in 1994 to that in 1995?
Offer a very short reply. 0.83. What is the ratio of the Rent(as % of GDP) of Dominica in 1994 to that in 1995?
Your response must be concise. 0.78. What is the ratio of the Rent(as % of GDP) in Ecuador in 1994 to that in 1995?
Your answer should be compact. 0.68. What is the ratio of the Rent(as % of GDP) of Israel in 1994 to that in 1995?
Keep it short and to the point. 1.22. What is the ratio of the Rent(as % of GDP) of Burkina Faso in 1994 to that in 1996?
Offer a very short reply. 0.9. What is the ratio of the Rent(as % of GDP) in Dominica in 1994 to that in 1996?
Offer a terse response. 1.19. What is the ratio of the Rent(as % of GDP) of Ecuador in 1994 to that in 1996?
Offer a terse response. 0.72. What is the ratio of the Rent(as % of GDP) of Israel in 1994 to that in 1996?
Give a very brief answer. 1.49. What is the ratio of the Rent(as % of GDP) in Burkina Faso in 1994 to that in 1997?
Your response must be concise. 0.91. What is the ratio of the Rent(as % of GDP) of Dominica in 1994 to that in 1997?
Provide a succinct answer. 0.8. What is the ratio of the Rent(as % of GDP) of Ecuador in 1994 to that in 1997?
Your response must be concise. 0.86. What is the ratio of the Rent(as % of GDP) in Israel in 1994 to that in 1997?
Ensure brevity in your answer.  1.46. What is the ratio of the Rent(as % of GDP) of Dominica in 1994 to that in 1998?
Keep it short and to the point. 1. What is the ratio of the Rent(as % of GDP) of Ecuador in 1994 to that in 1998?
Ensure brevity in your answer.  0.99. What is the ratio of the Rent(as % of GDP) in Israel in 1994 to that in 1998?
Offer a very short reply. 1.7. What is the ratio of the Rent(as % of GDP) of Burkina Faso in 1994 to that in 1999?
Your answer should be very brief. 2.23. What is the ratio of the Rent(as % of GDP) of Dominica in 1994 to that in 1999?
Your answer should be compact. 1.28. What is the ratio of the Rent(as % of GDP) in Ecuador in 1994 to that in 1999?
Ensure brevity in your answer.  2.44. What is the ratio of the Rent(as % of GDP) of Israel in 1994 to that in 1999?
Offer a terse response. 1.95. What is the ratio of the Rent(as % of GDP) in Burkina Faso in 1994 to that in 2000?
Ensure brevity in your answer.  1.93. What is the ratio of the Rent(as % of GDP) of Dominica in 1994 to that in 2000?
Your response must be concise. 1.64. What is the ratio of the Rent(as % of GDP) of Ecuador in 1994 to that in 2000?
Ensure brevity in your answer.  2.4. What is the ratio of the Rent(as % of GDP) of Israel in 1994 to that in 2000?
Provide a succinct answer. 3.18. What is the ratio of the Rent(as % of GDP) of Burkina Faso in 1995 to that in 1996?
Provide a succinct answer. 1.08. What is the ratio of the Rent(as % of GDP) in Dominica in 1995 to that in 1996?
Your response must be concise. 1.52. What is the ratio of the Rent(as % of GDP) in Ecuador in 1995 to that in 1996?
Your answer should be compact. 1.06. What is the ratio of the Rent(as % of GDP) of Israel in 1995 to that in 1996?
Provide a succinct answer. 1.23. What is the ratio of the Rent(as % of GDP) in Burkina Faso in 1995 to that in 1997?
Make the answer very short. 1.09. What is the ratio of the Rent(as % of GDP) in Dominica in 1995 to that in 1997?
Provide a succinct answer. 1.02. What is the ratio of the Rent(as % of GDP) of Ecuador in 1995 to that in 1997?
Your answer should be very brief. 1.27. What is the ratio of the Rent(as % of GDP) in Israel in 1995 to that in 1997?
Keep it short and to the point. 1.2. What is the ratio of the Rent(as % of GDP) of Burkina Faso in 1995 to that in 1998?
Ensure brevity in your answer.  1.19. What is the ratio of the Rent(as % of GDP) of Dominica in 1995 to that in 1998?
Provide a short and direct response. 1.28. What is the ratio of the Rent(as % of GDP) in Ecuador in 1995 to that in 1998?
Provide a succinct answer. 1.45. What is the ratio of the Rent(as % of GDP) in Israel in 1995 to that in 1998?
Provide a short and direct response. 1.4. What is the ratio of the Rent(as % of GDP) of Burkina Faso in 1995 to that in 1999?
Keep it short and to the point. 2.67. What is the ratio of the Rent(as % of GDP) of Dominica in 1995 to that in 1999?
Your answer should be very brief. 1.64. What is the ratio of the Rent(as % of GDP) in Ecuador in 1995 to that in 1999?
Make the answer very short. 3.6. What is the ratio of the Rent(as % of GDP) in Burkina Faso in 1995 to that in 2000?
Provide a short and direct response. 2.31. What is the ratio of the Rent(as % of GDP) in Dominica in 1995 to that in 2000?
Ensure brevity in your answer.  2.09. What is the ratio of the Rent(as % of GDP) in Ecuador in 1995 to that in 2000?
Ensure brevity in your answer.  3.54. What is the ratio of the Rent(as % of GDP) in Israel in 1995 to that in 2000?
Keep it short and to the point. 2.61. What is the ratio of the Rent(as % of GDP) in Dominica in 1996 to that in 1997?
Your response must be concise. 0.67. What is the ratio of the Rent(as % of GDP) in Ecuador in 1996 to that in 1997?
Provide a succinct answer. 1.19. What is the ratio of the Rent(as % of GDP) in Israel in 1996 to that in 1997?
Offer a very short reply. 0.98. What is the ratio of the Rent(as % of GDP) in Burkina Faso in 1996 to that in 1998?
Keep it short and to the point. 1.1. What is the ratio of the Rent(as % of GDP) in Dominica in 1996 to that in 1998?
Offer a terse response. 0.84. What is the ratio of the Rent(as % of GDP) in Ecuador in 1996 to that in 1998?
Your answer should be very brief. 1.36. What is the ratio of the Rent(as % of GDP) in Israel in 1996 to that in 1998?
Provide a short and direct response. 1.14. What is the ratio of the Rent(as % of GDP) of Burkina Faso in 1996 to that in 1999?
Your answer should be very brief. 2.46. What is the ratio of the Rent(as % of GDP) in Dominica in 1996 to that in 1999?
Ensure brevity in your answer.  1.08. What is the ratio of the Rent(as % of GDP) of Ecuador in 1996 to that in 1999?
Give a very brief answer. 3.38. What is the ratio of the Rent(as % of GDP) of Israel in 1996 to that in 1999?
Ensure brevity in your answer.  1.3. What is the ratio of the Rent(as % of GDP) in Burkina Faso in 1996 to that in 2000?
Give a very brief answer. 2.13. What is the ratio of the Rent(as % of GDP) of Dominica in 1996 to that in 2000?
Keep it short and to the point. 1.38. What is the ratio of the Rent(as % of GDP) in Ecuador in 1996 to that in 2000?
Your answer should be compact. 3.33. What is the ratio of the Rent(as % of GDP) in Israel in 1996 to that in 2000?
Your answer should be very brief. 2.13. What is the ratio of the Rent(as % of GDP) in Burkina Faso in 1997 to that in 1998?
Offer a very short reply. 1.09. What is the ratio of the Rent(as % of GDP) in Dominica in 1997 to that in 1998?
Offer a terse response. 1.25. What is the ratio of the Rent(as % of GDP) of Ecuador in 1997 to that in 1998?
Ensure brevity in your answer.  1.14. What is the ratio of the Rent(as % of GDP) of Israel in 1997 to that in 1998?
Make the answer very short. 1.16. What is the ratio of the Rent(as % of GDP) of Burkina Faso in 1997 to that in 1999?
Make the answer very short. 2.45. What is the ratio of the Rent(as % of GDP) in Dominica in 1997 to that in 1999?
Ensure brevity in your answer.  1.6. What is the ratio of the Rent(as % of GDP) of Ecuador in 1997 to that in 1999?
Offer a terse response. 2.84. What is the ratio of the Rent(as % of GDP) of Israel in 1997 to that in 1999?
Keep it short and to the point. 1.33. What is the ratio of the Rent(as % of GDP) of Burkina Faso in 1997 to that in 2000?
Ensure brevity in your answer.  2.12. What is the ratio of the Rent(as % of GDP) in Dominica in 1997 to that in 2000?
Your answer should be compact. 2.04. What is the ratio of the Rent(as % of GDP) of Ecuador in 1997 to that in 2000?
Give a very brief answer. 2.79. What is the ratio of the Rent(as % of GDP) in Israel in 1997 to that in 2000?
Offer a terse response. 2.17. What is the ratio of the Rent(as % of GDP) in Burkina Faso in 1998 to that in 1999?
Keep it short and to the point. 2.25. What is the ratio of the Rent(as % of GDP) in Dominica in 1998 to that in 1999?
Your answer should be compact. 1.28. What is the ratio of the Rent(as % of GDP) of Ecuador in 1998 to that in 1999?
Keep it short and to the point. 2.48. What is the ratio of the Rent(as % of GDP) of Israel in 1998 to that in 1999?
Make the answer very short. 1.14. What is the ratio of the Rent(as % of GDP) of Burkina Faso in 1998 to that in 2000?
Offer a terse response. 1.94. What is the ratio of the Rent(as % of GDP) of Dominica in 1998 to that in 2000?
Ensure brevity in your answer.  1.63. What is the ratio of the Rent(as % of GDP) of Ecuador in 1998 to that in 2000?
Offer a very short reply. 2.44. What is the ratio of the Rent(as % of GDP) of Israel in 1998 to that in 2000?
Your answer should be compact. 1.87. What is the ratio of the Rent(as % of GDP) of Burkina Faso in 1999 to that in 2000?
Your response must be concise. 0.87. What is the ratio of the Rent(as % of GDP) in Dominica in 1999 to that in 2000?
Your answer should be compact. 1.28. What is the ratio of the Rent(as % of GDP) in Ecuador in 1999 to that in 2000?
Provide a short and direct response. 0.98. What is the ratio of the Rent(as % of GDP) of Israel in 1999 to that in 2000?
Your answer should be very brief. 1.63. What is the difference between the highest and the second highest Rent(as % of GDP) in Burkina Faso?
Provide a succinct answer. 1.07. What is the difference between the highest and the second highest Rent(as % of GDP) in Dominica?
Provide a short and direct response. 0. What is the difference between the highest and the second highest Rent(as % of GDP) of Ecuador?
Give a very brief answer. 0.19. What is the difference between the highest and the second highest Rent(as % of GDP) in Israel?
Ensure brevity in your answer.  0. What is the difference between the highest and the lowest Rent(as % of GDP) of Burkina Faso?
Provide a short and direct response. 8.63. What is the difference between the highest and the lowest Rent(as % of GDP) of Dominica?
Offer a terse response. 0.07. What is the difference between the highest and the lowest Rent(as % of GDP) in Ecuador?
Your answer should be very brief. 2.28. What is the difference between the highest and the lowest Rent(as % of GDP) in Israel?
Offer a very short reply. 0.01. 